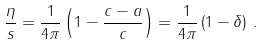<formula> <loc_0><loc_0><loc_500><loc_500>\frac { \eta } { s } = \frac { 1 } { 4 \pi } \left ( 1 - \frac { c - a } { c } \right ) = \frac { 1 } { 4 \pi } \left ( 1 - \delta \right ) \, .</formula> 